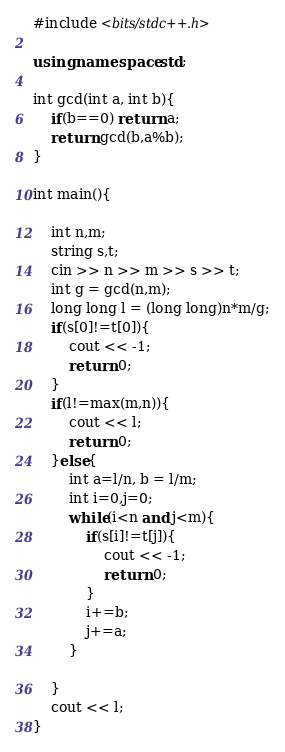Convert code to text. <code><loc_0><loc_0><loc_500><loc_500><_C++_>#include <bits/stdc++.h>

using namespace std;

int gcd(int a, int b){
	if(b==0) return a;
	return gcd(b,a%b);
}

int main(){

	int n,m;
	string s,t;
	cin >> n >> m >> s >> t;
	int g = gcd(n,m);
	long long l = (long long)n*m/g;
	if(s[0]!=t[0]){
		cout << -1;
		return 0;
	}
	if(l!=max(m,n)){
		cout << l;
		return 0;
	}else{
		int a=l/n, b = l/m;
		int i=0,j=0;
		while(i<n and j<m){
			if(s[i]!=t[j]){
				cout << -1;
				return 0;
			}
			i+=b;
			j+=a;
		}

	}
	cout << l;
}</code> 